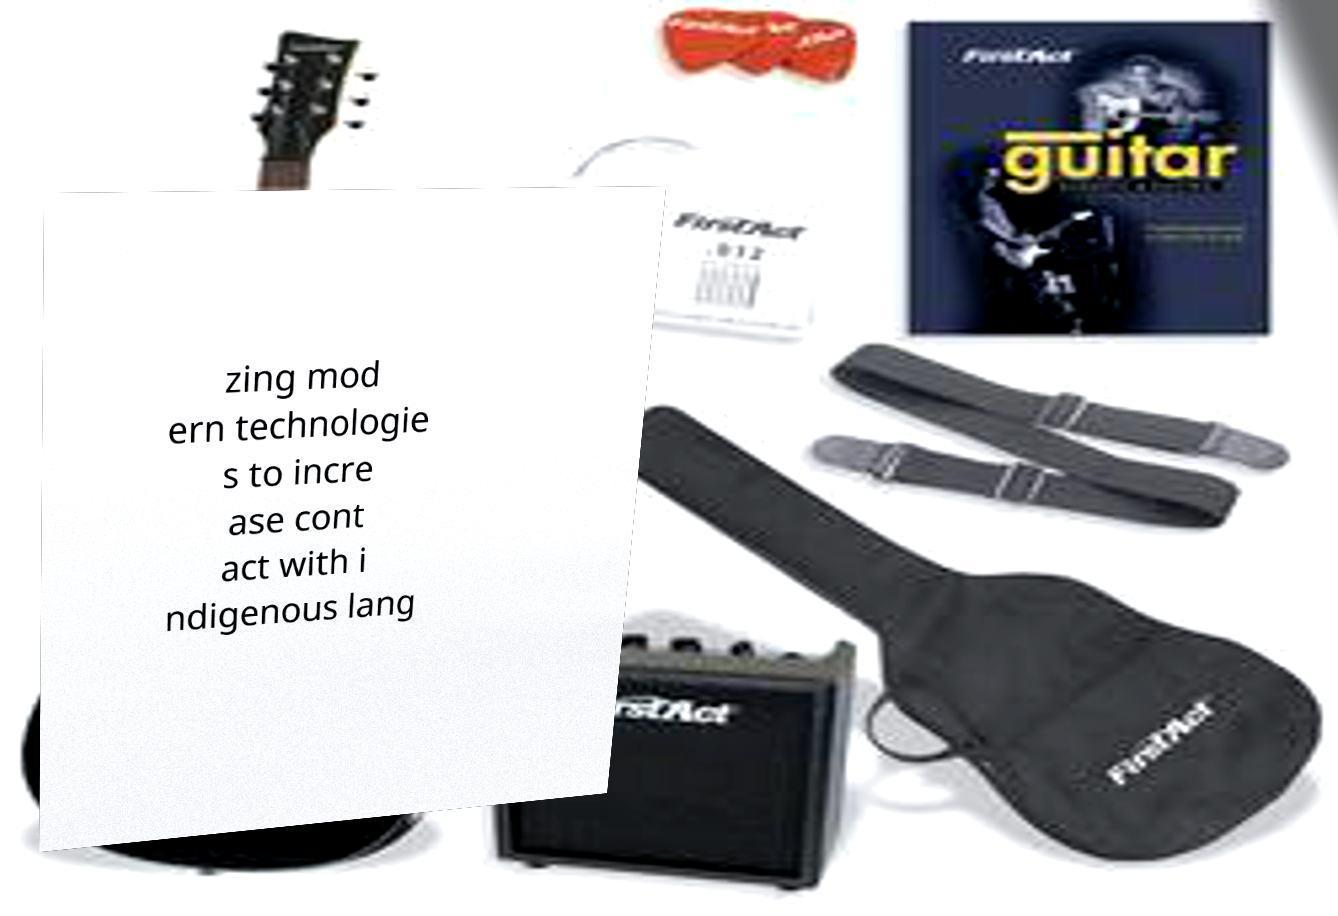Could you assist in decoding the text presented in this image and type it out clearly? zing mod ern technologie s to incre ase cont act with i ndigenous lang 